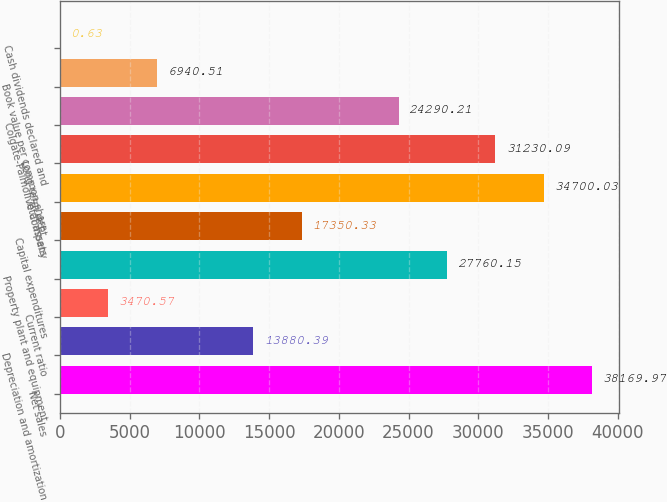Convert chart. <chart><loc_0><loc_0><loc_500><loc_500><bar_chart><fcel>Net sales<fcel>Depreciation and amortization<fcel>Current ratio<fcel>Property plant and equipment<fcel>Capital expenditures<fcel>Total assets<fcel>Long-term debt<fcel>Colgate-Palmolive Company<fcel>Book value per common share<fcel>Cash dividends declared and<nl><fcel>38170<fcel>13880.4<fcel>3470.57<fcel>27760.2<fcel>17350.3<fcel>34700<fcel>31230.1<fcel>24290.2<fcel>6940.51<fcel>0.63<nl></chart> 